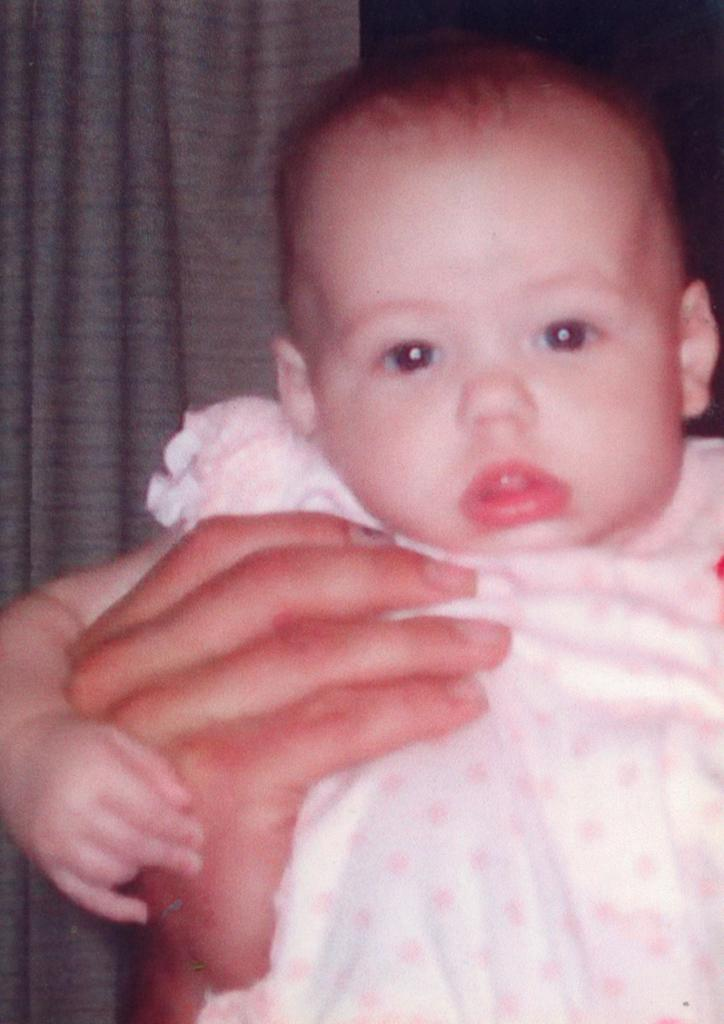What is the main subject of the image? There is a small kid in the image. Who is interacting with the kid in the image? A person is holding the kid. What can be seen in the background of the image? There is a gray curtain in the background of the image. What is the kid wearing in the image? The kid is wearing a white and pink dress. Can you see any yaks in the image? No, there are no yaks present in the image. What type of leaf is being used as a prop in the image? There are no leaves present in the image. 